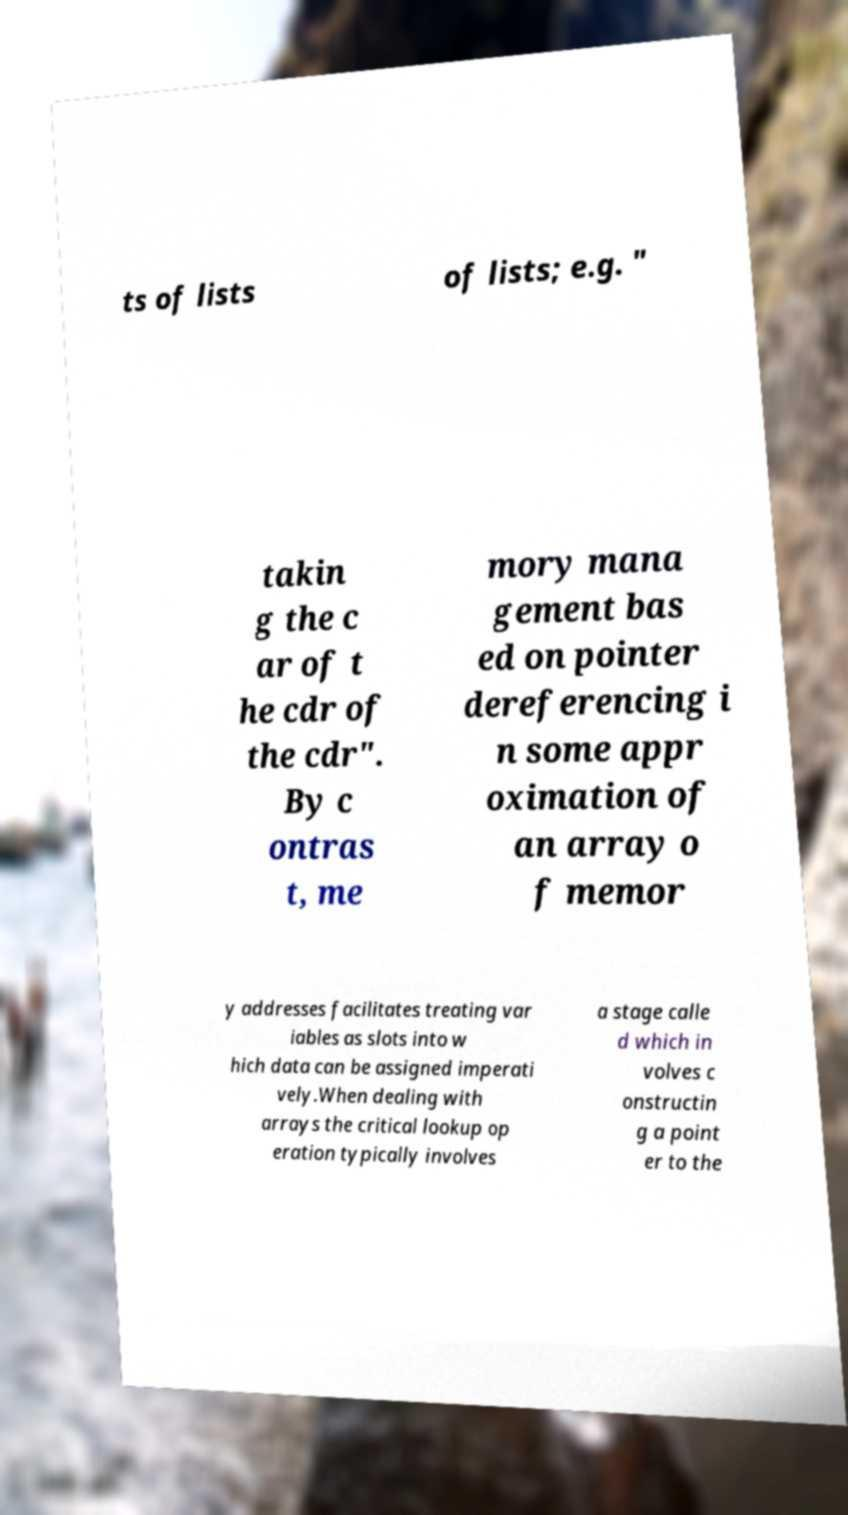Can you read and provide the text displayed in the image?This photo seems to have some interesting text. Can you extract and type it out for me? ts of lists of lists; e.g. " takin g the c ar of t he cdr of the cdr". By c ontras t, me mory mana gement bas ed on pointer dereferencing i n some appr oximation of an array o f memor y addresses facilitates treating var iables as slots into w hich data can be assigned imperati vely.When dealing with arrays the critical lookup op eration typically involves a stage calle d which in volves c onstructin g a point er to the 